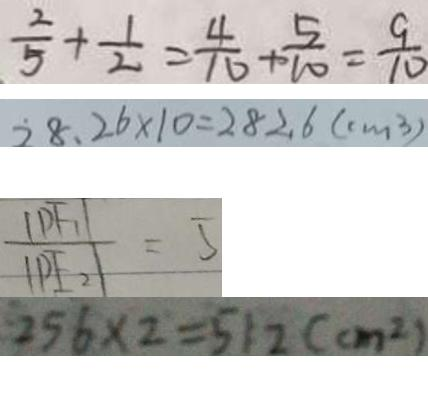Convert formula to latex. <formula><loc_0><loc_0><loc_500><loc_500>\frac { 2 } { 5 } + \frac { 1 } { 2 } = \frac { 4 } { 1 6 } + \frac { 5 } { 1 0 } = \frac { 9 } { 1 0 } 
 2 8 . 2 6 \times 1 0 = 2 8 2 . 6 ( c m ^ { 3 } ) 
 \frac { \vert P F _ { 1 } \vert } { \vert P F _ { 2 } \vert } = 5 
 2 5 6 \times 2 = 5 1 2 ( c m ^ { 2 } )</formula> 